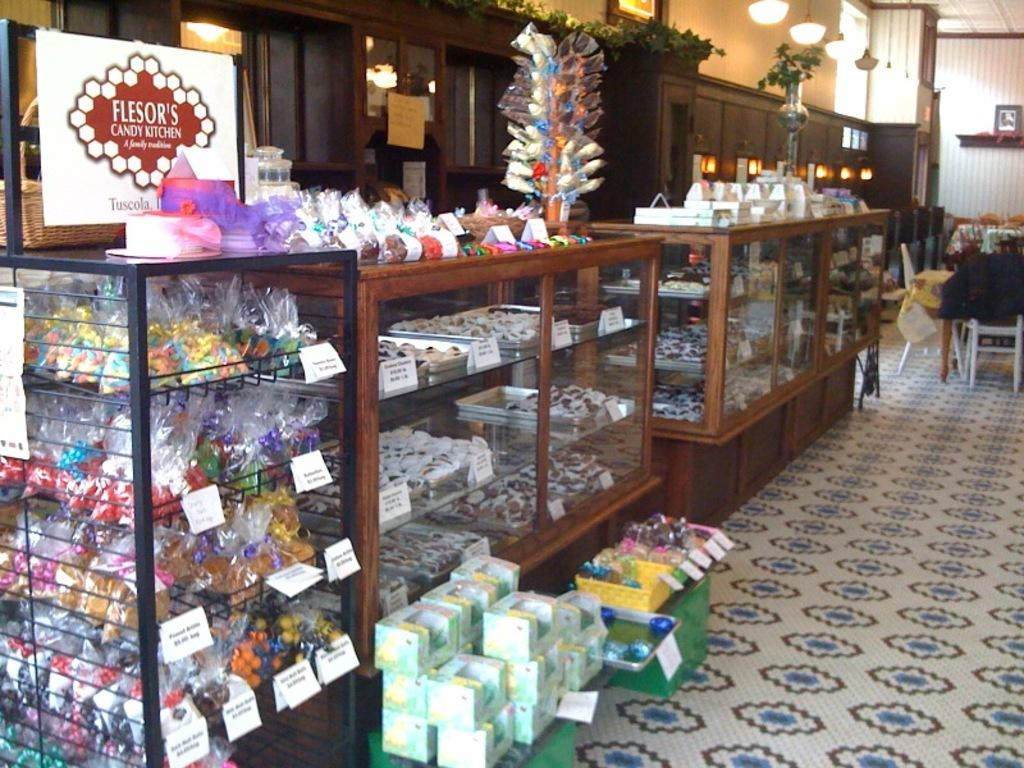<image>
Present a compact description of the photo's key features. A cute candy shop with cases and shelves displaying all kinds of candy for Flesor's Candy Kitchen 